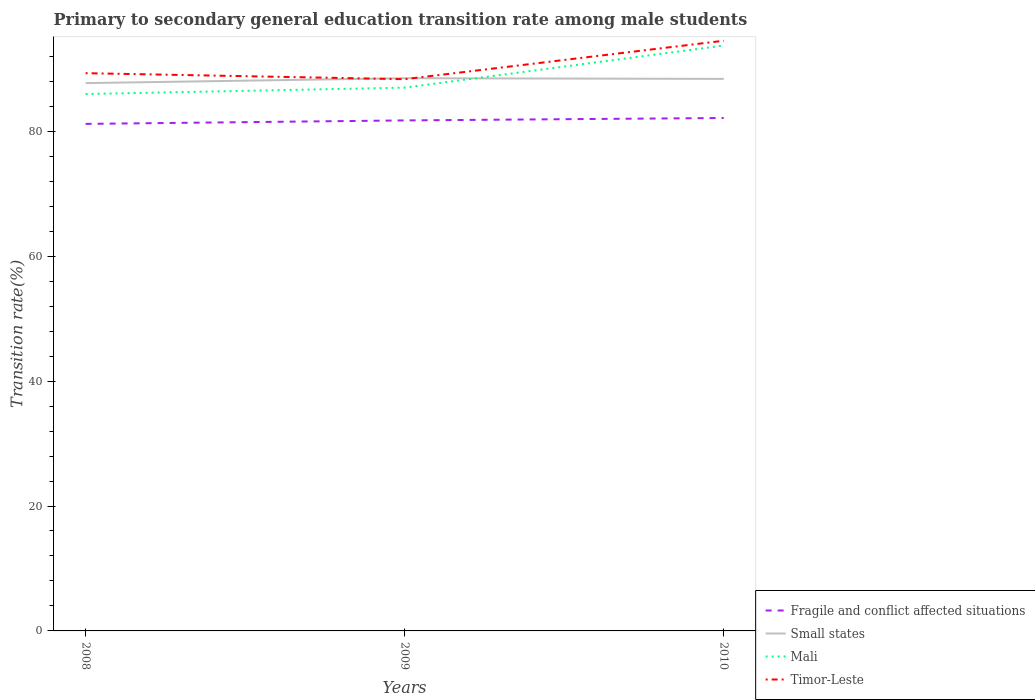How many different coloured lines are there?
Keep it short and to the point. 4. Across all years, what is the maximum transition rate in Fragile and conflict affected situations?
Give a very brief answer. 81.18. What is the total transition rate in Small states in the graph?
Your answer should be compact. -0.78. What is the difference between the highest and the second highest transition rate in Mali?
Make the answer very short. 7.77. Is the transition rate in Small states strictly greater than the transition rate in Mali over the years?
Your response must be concise. No. How many lines are there?
Keep it short and to the point. 4. How many years are there in the graph?
Give a very brief answer. 3. What is the difference between two consecutive major ticks on the Y-axis?
Keep it short and to the point. 20. Are the values on the major ticks of Y-axis written in scientific E-notation?
Keep it short and to the point. No. Does the graph contain grids?
Your answer should be very brief. No. Where does the legend appear in the graph?
Ensure brevity in your answer.  Bottom right. What is the title of the graph?
Your response must be concise. Primary to secondary general education transition rate among male students. Does "Sri Lanka" appear as one of the legend labels in the graph?
Your answer should be very brief. No. What is the label or title of the Y-axis?
Offer a very short reply. Transition rate(%). What is the Transition rate(%) in Fragile and conflict affected situations in 2008?
Your response must be concise. 81.18. What is the Transition rate(%) of Small states in 2008?
Ensure brevity in your answer.  87.71. What is the Transition rate(%) of Mali in 2008?
Your answer should be very brief. 85.97. What is the Transition rate(%) in Timor-Leste in 2008?
Your answer should be compact. 89.3. What is the Transition rate(%) of Fragile and conflict affected situations in 2009?
Ensure brevity in your answer.  81.74. What is the Transition rate(%) in Small states in 2009?
Offer a terse response. 88.5. What is the Transition rate(%) of Mali in 2009?
Ensure brevity in your answer.  86.99. What is the Transition rate(%) of Timor-Leste in 2009?
Your answer should be very brief. 88.34. What is the Transition rate(%) of Fragile and conflict affected situations in 2010?
Offer a very short reply. 82.13. What is the Transition rate(%) in Small states in 2010?
Your answer should be compact. 88.39. What is the Transition rate(%) in Mali in 2010?
Your answer should be compact. 93.73. What is the Transition rate(%) in Timor-Leste in 2010?
Ensure brevity in your answer.  94.5. Across all years, what is the maximum Transition rate(%) in Fragile and conflict affected situations?
Make the answer very short. 82.13. Across all years, what is the maximum Transition rate(%) of Small states?
Give a very brief answer. 88.5. Across all years, what is the maximum Transition rate(%) of Mali?
Your response must be concise. 93.73. Across all years, what is the maximum Transition rate(%) of Timor-Leste?
Offer a very short reply. 94.5. Across all years, what is the minimum Transition rate(%) of Fragile and conflict affected situations?
Offer a terse response. 81.18. Across all years, what is the minimum Transition rate(%) of Small states?
Make the answer very short. 87.71. Across all years, what is the minimum Transition rate(%) of Mali?
Your answer should be compact. 85.97. Across all years, what is the minimum Transition rate(%) in Timor-Leste?
Provide a succinct answer. 88.34. What is the total Transition rate(%) in Fragile and conflict affected situations in the graph?
Give a very brief answer. 245.06. What is the total Transition rate(%) in Small states in the graph?
Provide a short and direct response. 264.6. What is the total Transition rate(%) in Mali in the graph?
Your answer should be compact. 266.69. What is the total Transition rate(%) of Timor-Leste in the graph?
Provide a short and direct response. 272.15. What is the difference between the Transition rate(%) in Fragile and conflict affected situations in 2008 and that in 2009?
Give a very brief answer. -0.56. What is the difference between the Transition rate(%) in Small states in 2008 and that in 2009?
Ensure brevity in your answer.  -0.78. What is the difference between the Transition rate(%) of Mali in 2008 and that in 2009?
Provide a succinct answer. -1.02. What is the difference between the Transition rate(%) of Fragile and conflict affected situations in 2008 and that in 2010?
Provide a short and direct response. -0.95. What is the difference between the Transition rate(%) of Small states in 2008 and that in 2010?
Ensure brevity in your answer.  -0.68. What is the difference between the Transition rate(%) of Mali in 2008 and that in 2010?
Your answer should be compact. -7.77. What is the difference between the Transition rate(%) of Timor-Leste in 2008 and that in 2010?
Your response must be concise. -5.19. What is the difference between the Transition rate(%) of Fragile and conflict affected situations in 2009 and that in 2010?
Provide a short and direct response. -0.39. What is the difference between the Transition rate(%) in Small states in 2009 and that in 2010?
Keep it short and to the point. 0.11. What is the difference between the Transition rate(%) in Mali in 2009 and that in 2010?
Keep it short and to the point. -6.74. What is the difference between the Transition rate(%) of Timor-Leste in 2009 and that in 2010?
Give a very brief answer. -6.16. What is the difference between the Transition rate(%) of Fragile and conflict affected situations in 2008 and the Transition rate(%) of Small states in 2009?
Your answer should be very brief. -7.31. What is the difference between the Transition rate(%) in Fragile and conflict affected situations in 2008 and the Transition rate(%) in Mali in 2009?
Provide a succinct answer. -5.81. What is the difference between the Transition rate(%) of Fragile and conflict affected situations in 2008 and the Transition rate(%) of Timor-Leste in 2009?
Offer a very short reply. -7.16. What is the difference between the Transition rate(%) of Small states in 2008 and the Transition rate(%) of Mali in 2009?
Provide a succinct answer. 0.72. What is the difference between the Transition rate(%) in Small states in 2008 and the Transition rate(%) in Timor-Leste in 2009?
Make the answer very short. -0.63. What is the difference between the Transition rate(%) in Mali in 2008 and the Transition rate(%) in Timor-Leste in 2009?
Offer a terse response. -2.38. What is the difference between the Transition rate(%) in Fragile and conflict affected situations in 2008 and the Transition rate(%) in Small states in 2010?
Your answer should be compact. -7.21. What is the difference between the Transition rate(%) of Fragile and conflict affected situations in 2008 and the Transition rate(%) of Mali in 2010?
Your answer should be compact. -12.55. What is the difference between the Transition rate(%) of Fragile and conflict affected situations in 2008 and the Transition rate(%) of Timor-Leste in 2010?
Your response must be concise. -13.31. What is the difference between the Transition rate(%) in Small states in 2008 and the Transition rate(%) in Mali in 2010?
Provide a short and direct response. -6.02. What is the difference between the Transition rate(%) of Small states in 2008 and the Transition rate(%) of Timor-Leste in 2010?
Provide a succinct answer. -6.78. What is the difference between the Transition rate(%) in Mali in 2008 and the Transition rate(%) in Timor-Leste in 2010?
Provide a short and direct response. -8.53. What is the difference between the Transition rate(%) of Fragile and conflict affected situations in 2009 and the Transition rate(%) of Small states in 2010?
Keep it short and to the point. -6.65. What is the difference between the Transition rate(%) in Fragile and conflict affected situations in 2009 and the Transition rate(%) in Mali in 2010?
Offer a very short reply. -11.99. What is the difference between the Transition rate(%) of Fragile and conflict affected situations in 2009 and the Transition rate(%) of Timor-Leste in 2010?
Give a very brief answer. -12.76. What is the difference between the Transition rate(%) in Small states in 2009 and the Transition rate(%) in Mali in 2010?
Your answer should be very brief. -5.24. What is the difference between the Transition rate(%) in Small states in 2009 and the Transition rate(%) in Timor-Leste in 2010?
Your response must be concise. -6. What is the difference between the Transition rate(%) of Mali in 2009 and the Transition rate(%) of Timor-Leste in 2010?
Your response must be concise. -7.51. What is the average Transition rate(%) in Fragile and conflict affected situations per year?
Ensure brevity in your answer.  81.69. What is the average Transition rate(%) in Small states per year?
Give a very brief answer. 88.2. What is the average Transition rate(%) of Mali per year?
Give a very brief answer. 88.9. What is the average Transition rate(%) in Timor-Leste per year?
Offer a terse response. 90.72. In the year 2008, what is the difference between the Transition rate(%) of Fragile and conflict affected situations and Transition rate(%) of Small states?
Give a very brief answer. -6.53. In the year 2008, what is the difference between the Transition rate(%) of Fragile and conflict affected situations and Transition rate(%) of Mali?
Give a very brief answer. -4.78. In the year 2008, what is the difference between the Transition rate(%) of Fragile and conflict affected situations and Transition rate(%) of Timor-Leste?
Your answer should be very brief. -8.12. In the year 2008, what is the difference between the Transition rate(%) of Small states and Transition rate(%) of Mali?
Your response must be concise. 1.75. In the year 2008, what is the difference between the Transition rate(%) in Small states and Transition rate(%) in Timor-Leste?
Keep it short and to the point. -1.59. In the year 2008, what is the difference between the Transition rate(%) of Mali and Transition rate(%) of Timor-Leste?
Ensure brevity in your answer.  -3.34. In the year 2009, what is the difference between the Transition rate(%) in Fragile and conflict affected situations and Transition rate(%) in Small states?
Give a very brief answer. -6.75. In the year 2009, what is the difference between the Transition rate(%) of Fragile and conflict affected situations and Transition rate(%) of Mali?
Give a very brief answer. -5.25. In the year 2009, what is the difference between the Transition rate(%) in Fragile and conflict affected situations and Transition rate(%) in Timor-Leste?
Your answer should be very brief. -6.6. In the year 2009, what is the difference between the Transition rate(%) of Small states and Transition rate(%) of Mali?
Your answer should be very brief. 1.51. In the year 2009, what is the difference between the Transition rate(%) of Small states and Transition rate(%) of Timor-Leste?
Make the answer very short. 0.15. In the year 2009, what is the difference between the Transition rate(%) in Mali and Transition rate(%) in Timor-Leste?
Provide a short and direct response. -1.35. In the year 2010, what is the difference between the Transition rate(%) of Fragile and conflict affected situations and Transition rate(%) of Small states?
Offer a very short reply. -6.26. In the year 2010, what is the difference between the Transition rate(%) in Fragile and conflict affected situations and Transition rate(%) in Mali?
Keep it short and to the point. -11.6. In the year 2010, what is the difference between the Transition rate(%) of Fragile and conflict affected situations and Transition rate(%) of Timor-Leste?
Offer a very short reply. -12.37. In the year 2010, what is the difference between the Transition rate(%) in Small states and Transition rate(%) in Mali?
Give a very brief answer. -5.34. In the year 2010, what is the difference between the Transition rate(%) in Small states and Transition rate(%) in Timor-Leste?
Make the answer very short. -6.11. In the year 2010, what is the difference between the Transition rate(%) of Mali and Transition rate(%) of Timor-Leste?
Provide a short and direct response. -0.77. What is the ratio of the Transition rate(%) of Small states in 2008 to that in 2009?
Provide a short and direct response. 0.99. What is the ratio of the Transition rate(%) in Timor-Leste in 2008 to that in 2009?
Offer a terse response. 1.01. What is the ratio of the Transition rate(%) of Fragile and conflict affected situations in 2008 to that in 2010?
Your answer should be very brief. 0.99. What is the ratio of the Transition rate(%) of Mali in 2008 to that in 2010?
Make the answer very short. 0.92. What is the ratio of the Transition rate(%) in Timor-Leste in 2008 to that in 2010?
Provide a succinct answer. 0.94. What is the ratio of the Transition rate(%) in Fragile and conflict affected situations in 2009 to that in 2010?
Keep it short and to the point. 1. What is the ratio of the Transition rate(%) of Small states in 2009 to that in 2010?
Provide a short and direct response. 1. What is the ratio of the Transition rate(%) of Mali in 2009 to that in 2010?
Offer a terse response. 0.93. What is the ratio of the Transition rate(%) of Timor-Leste in 2009 to that in 2010?
Make the answer very short. 0.93. What is the difference between the highest and the second highest Transition rate(%) in Fragile and conflict affected situations?
Keep it short and to the point. 0.39. What is the difference between the highest and the second highest Transition rate(%) in Small states?
Provide a short and direct response. 0.11. What is the difference between the highest and the second highest Transition rate(%) in Mali?
Provide a succinct answer. 6.74. What is the difference between the highest and the second highest Transition rate(%) in Timor-Leste?
Provide a short and direct response. 5.19. What is the difference between the highest and the lowest Transition rate(%) in Fragile and conflict affected situations?
Keep it short and to the point. 0.95. What is the difference between the highest and the lowest Transition rate(%) in Small states?
Give a very brief answer. 0.78. What is the difference between the highest and the lowest Transition rate(%) in Mali?
Offer a terse response. 7.77. What is the difference between the highest and the lowest Transition rate(%) in Timor-Leste?
Your answer should be very brief. 6.16. 